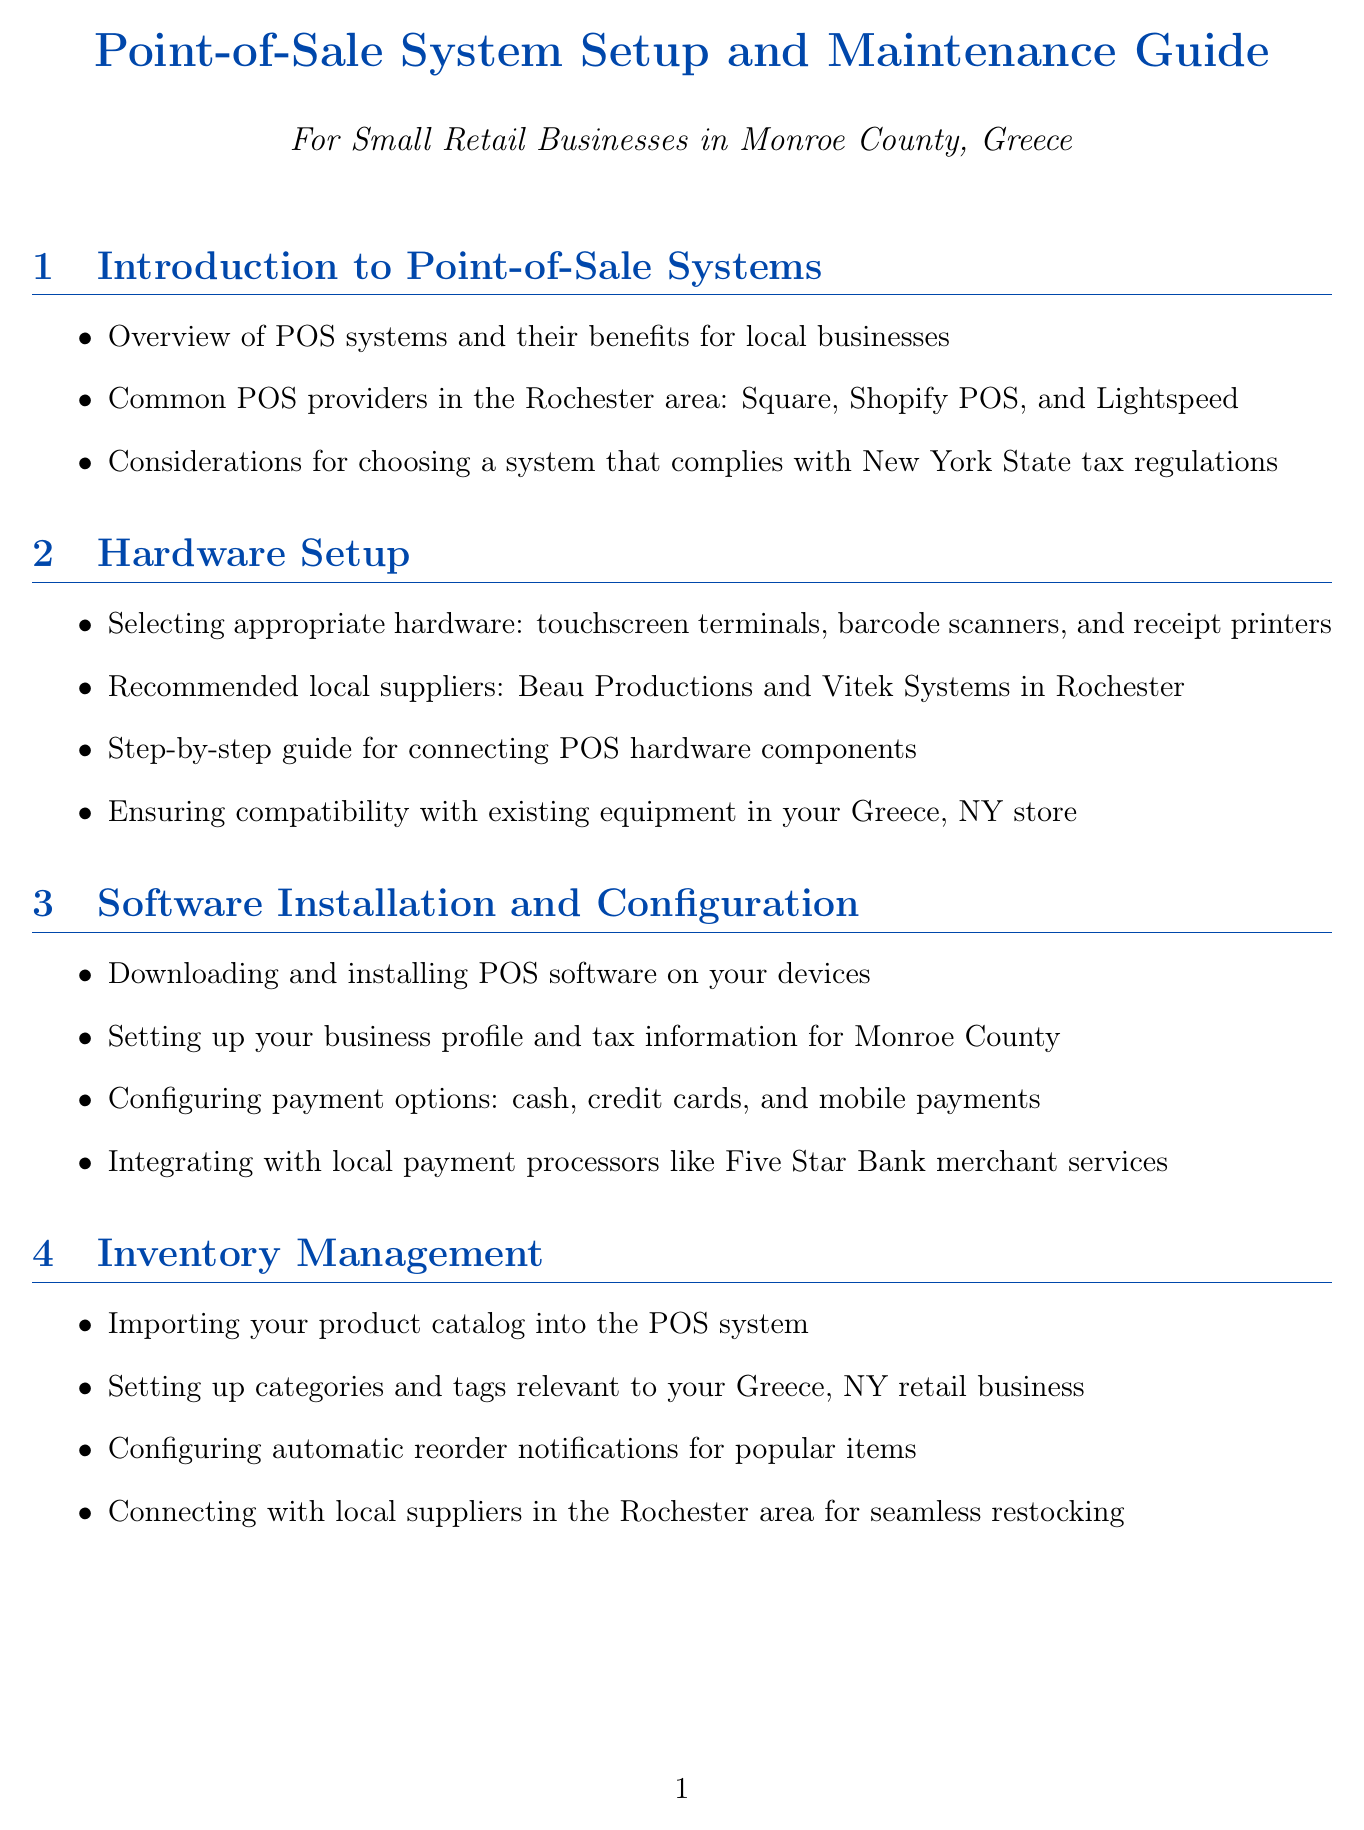What are the common POS providers? The document lists common POS providers in the Rochester area as Square, Shopify POS, and Lightspeed.
Answer: Square, Shopify POS, and Lightspeed Which local supplier is recommended for POS hardware? The document mentions local suppliers such as Beau Productions and Vitek Systems in Rochester for POS hardware.
Answer: Beau Productions and Vitek Systems What feature is suggested for inventory management? The document advises configuring automatic reorder notifications for popular items as a good inventory management feature.
Answer: Automatic reorder notifications How should you set up your business profile for software? It states that you should set up your business profile and tax information specifically for Monroe County.
Answer: Monroe County What is a proposed local training resource? Monroe Community College's workforce development programs are mentioned as a resource for employee training.
Answer: Monroe Community College What compliance issue is highlighted for POS systems? The document highlights the importance of ensuring PCI DSS compliance for credit card transactions.
Answer: PCI DSS compliance What type of programs can be tailored for local customers? The document suggests setting up loyalty programs tailored to Greece, NY shoppers.
Answer: Loyalty programs Which local business association can provide ongoing support? It mentions participating in local business associations like the Greece Chamber of Commerce for ongoing support.
Answer: Greece Chamber of Commerce What is emphasized as crucial for maintaining the POS system? Regular software updates and security patches are emphasized as crucial maintenance tasks.
Answer: Software updates and security patches 